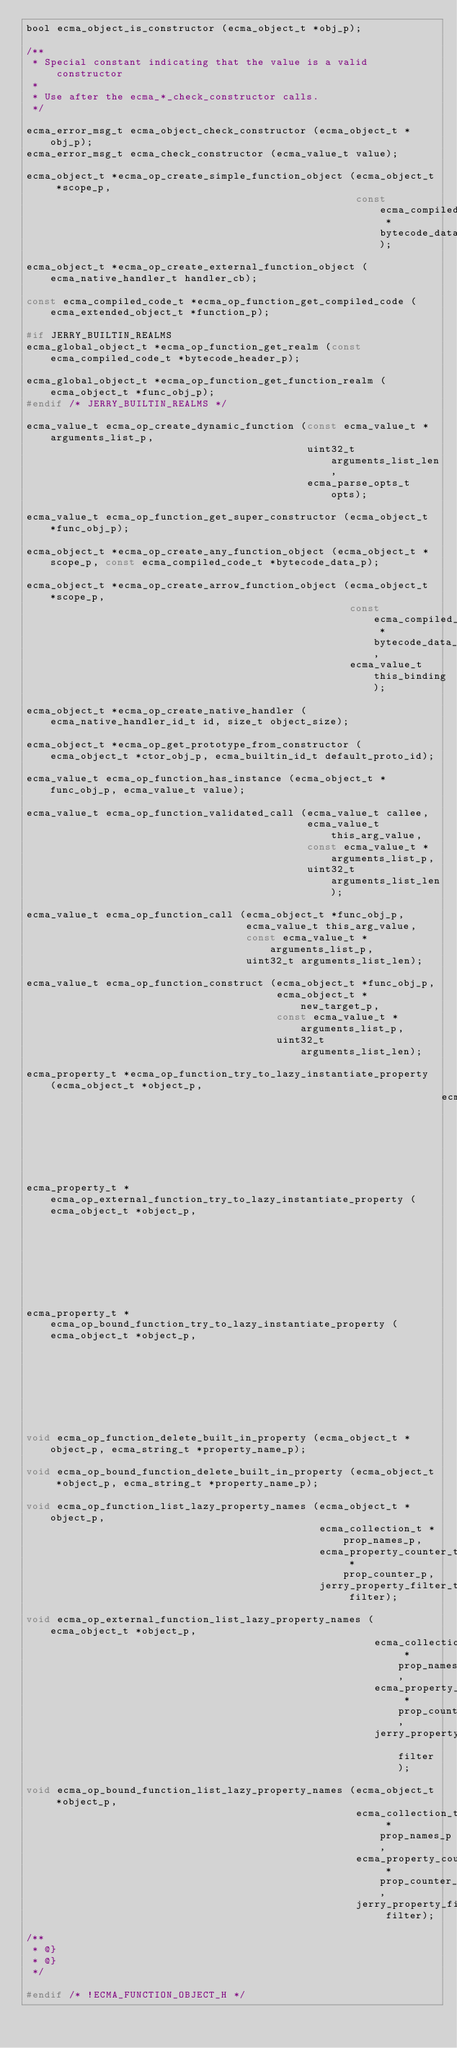<code> <loc_0><loc_0><loc_500><loc_500><_C_>bool ecma_object_is_constructor (ecma_object_t *obj_p);

/**
 * Special constant indicating that the value is a valid constructor
 *
 * Use after the ecma_*_check_constructor calls.
 */

ecma_error_msg_t ecma_object_check_constructor (ecma_object_t *obj_p);
ecma_error_msg_t ecma_check_constructor (ecma_value_t value);

ecma_object_t *ecma_op_create_simple_function_object (ecma_object_t *scope_p,
                                                      const ecma_compiled_code_t *bytecode_data_p);

ecma_object_t *ecma_op_create_external_function_object (ecma_native_handler_t handler_cb);

const ecma_compiled_code_t *ecma_op_function_get_compiled_code (ecma_extended_object_t *function_p);

#if JERRY_BUILTIN_REALMS
ecma_global_object_t *ecma_op_function_get_realm (const ecma_compiled_code_t *bytecode_header_p);

ecma_global_object_t *ecma_op_function_get_function_realm (ecma_object_t *func_obj_p);
#endif /* JERRY_BUILTIN_REALMS */

ecma_value_t ecma_op_create_dynamic_function (const ecma_value_t *arguments_list_p,
                                              uint32_t arguments_list_len,
                                              ecma_parse_opts_t opts);

ecma_value_t ecma_op_function_get_super_constructor (ecma_object_t *func_obj_p);

ecma_object_t *ecma_op_create_any_function_object (ecma_object_t *scope_p, const ecma_compiled_code_t *bytecode_data_p);

ecma_object_t *ecma_op_create_arrow_function_object (ecma_object_t *scope_p,
                                                     const ecma_compiled_code_t *bytecode_data_p,
                                                     ecma_value_t this_binding);

ecma_object_t *ecma_op_create_native_handler (ecma_native_handler_id_t id, size_t object_size);

ecma_object_t *ecma_op_get_prototype_from_constructor (ecma_object_t *ctor_obj_p, ecma_builtin_id_t default_proto_id);

ecma_value_t ecma_op_function_has_instance (ecma_object_t *func_obj_p, ecma_value_t value);

ecma_value_t ecma_op_function_validated_call (ecma_value_t callee,
                                              ecma_value_t this_arg_value,
                                              const ecma_value_t *arguments_list_p,
                                              uint32_t arguments_list_len);

ecma_value_t ecma_op_function_call (ecma_object_t *func_obj_p,
                                    ecma_value_t this_arg_value,
                                    const ecma_value_t *arguments_list_p,
                                    uint32_t arguments_list_len);

ecma_value_t ecma_op_function_construct (ecma_object_t *func_obj_p,
                                         ecma_object_t *new_target_p,
                                         const ecma_value_t *arguments_list_p,
                                         uint32_t arguments_list_len);

ecma_property_t *ecma_op_function_try_to_lazy_instantiate_property (ecma_object_t *object_p,
                                                                    ecma_string_t *property_name_p);

ecma_property_t *ecma_op_external_function_try_to_lazy_instantiate_property (ecma_object_t *object_p,
                                                                             ecma_string_t *property_name_p);

ecma_property_t *ecma_op_bound_function_try_to_lazy_instantiate_property (ecma_object_t *object_p,
                                                                          ecma_string_t *property_name_p);

void ecma_op_function_delete_built_in_property (ecma_object_t *object_p, ecma_string_t *property_name_p);

void ecma_op_bound_function_delete_built_in_property (ecma_object_t *object_p, ecma_string_t *property_name_p);

void ecma_op_function_list_lazy_property_names (ecma_object_t *object_p,
                                                ecma_collection_t *prop_names_p,
                                                ecma_property_counter_t *prop_counter_p,
                                                jerry_property_filter_t filter);

void ecma_op_external_function_list_lazy_property_names (ecma_object_t *object_p,
                                                         ecma_collection_t *prop_names_p,
                                                         ecma_property_counter_t *prop_counter_p,
                                                         jerry_property_filter_t filter);

void ecma_op_bound_function_list_lazy_property_names (ecma_object_t *object_p,
                                                      ecma_collection_t *prop_names_p,
                                                      ecma_property_counter_t *prop_counter_p,
                                                      jerry_property_filter_t filter);

/**
 * @}
 * @}
 */

#endif /* !ECMA_FUNCTION_OBJECT_H */
</code> 